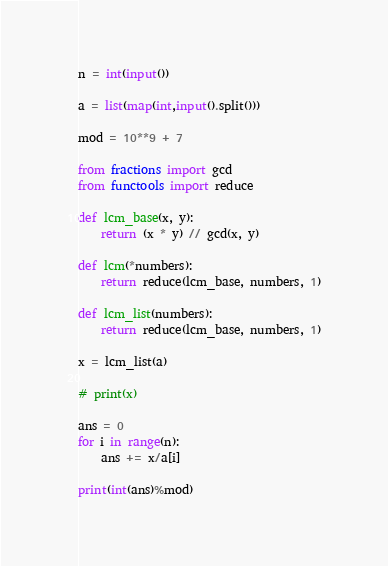<code> <loc_0><loc_0><loc_500><loc_500><_Python_>n = int(input())

a = list(map(int,input().split()))

mod = 10**9 + 7

from fractions import gcd
from functools import reduce

def lcm_base(x, y):
    return (x * y) // gcd(x, y)

def lcm(*numbers):
    return reduce(lcm_base, numbers, 1)

def lcm_list(numbers):
    return reduce(lcm_base, numbers, 1)

x = lcm_list(a)

# print(x)

ans = 0
for i in range(n):
    ans += x/a[i]

print(int(ans)%mod)</code> 